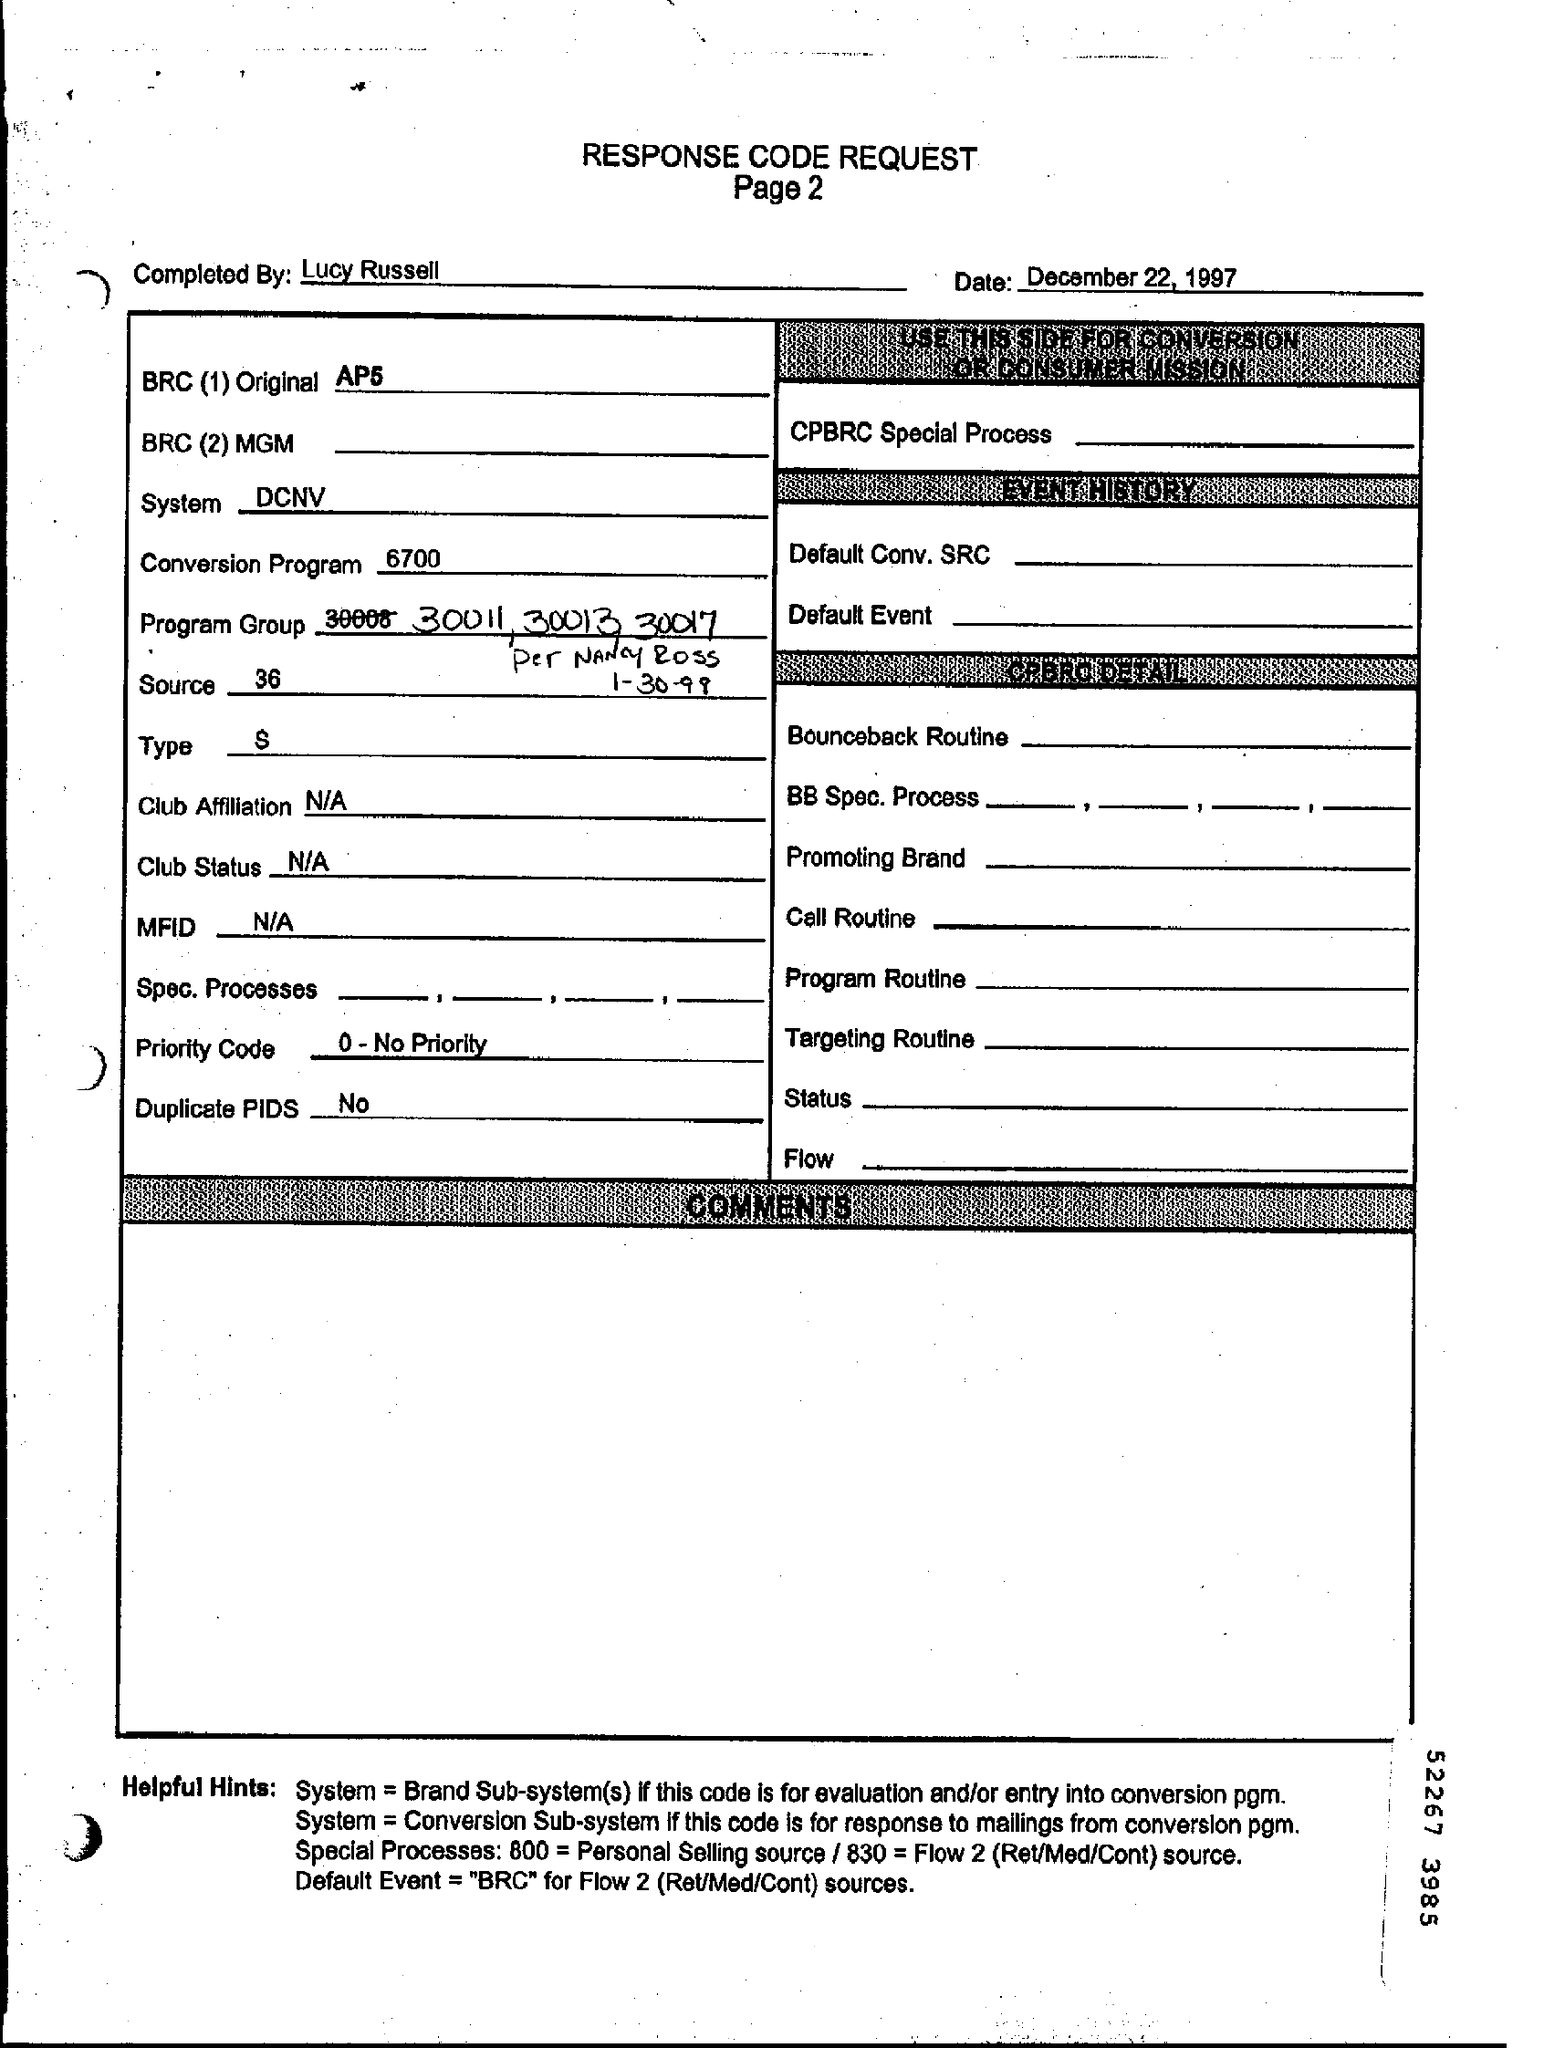Whats the TYPE?
Provide a succinct answer. S. Which System used in RESPONSE CODE REQUEST?
Offer a very short reply. DCNV. Who  completed the REQUEST?
Make the answer very short. Lucy Russell. Are there any Duplicate PIDS?
Provide a short and direct response. No. 